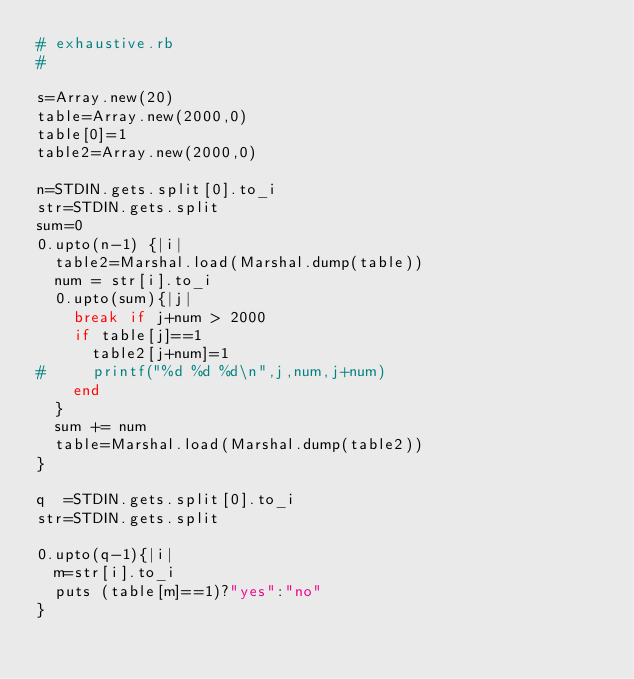Convert code to text. <code><loc_0><loc_0><loc_500><loc_500><_Ruby_># exhaustive.rb
#

s=Array.new(20)
table=Array.new(2000,0)
table[0]=1
table2=Array.new(2000,0)

n=STDIN.gets.split[0].to_i
str=STDIN.gets.split
sum=0
0.upto(n-1) {|i|
  table2=Marshal.load(Marshal.dump(table))
  num = str[i].to_i
  0.upto(sum){|j|
    break if j+num > 2000 
    if table[j]==1
      table2[j+num]=1 
#     printf("%d %d %d\n",j,num,j+num)
    end
  } 
  sum += num
  table=Marshal.load(Marshal.dump(table2))
}

q  =STDIN.gets.split[0].to_i
str=STDIN.gets.split

0.upto(q-1){|i|
  m=str[i].to_i
  puts (table[m]==1)?"yes":"no"
}
  </code> 